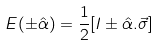Convert formula to latex. <formula><loc_0><loc_0><loc_500><loc_500>E ( \pm \hat { \alpha } ) = \frac { 1 } { 2 } [ I \pm \hat { \alpha } . \vec { \sigma } ]</formula> 